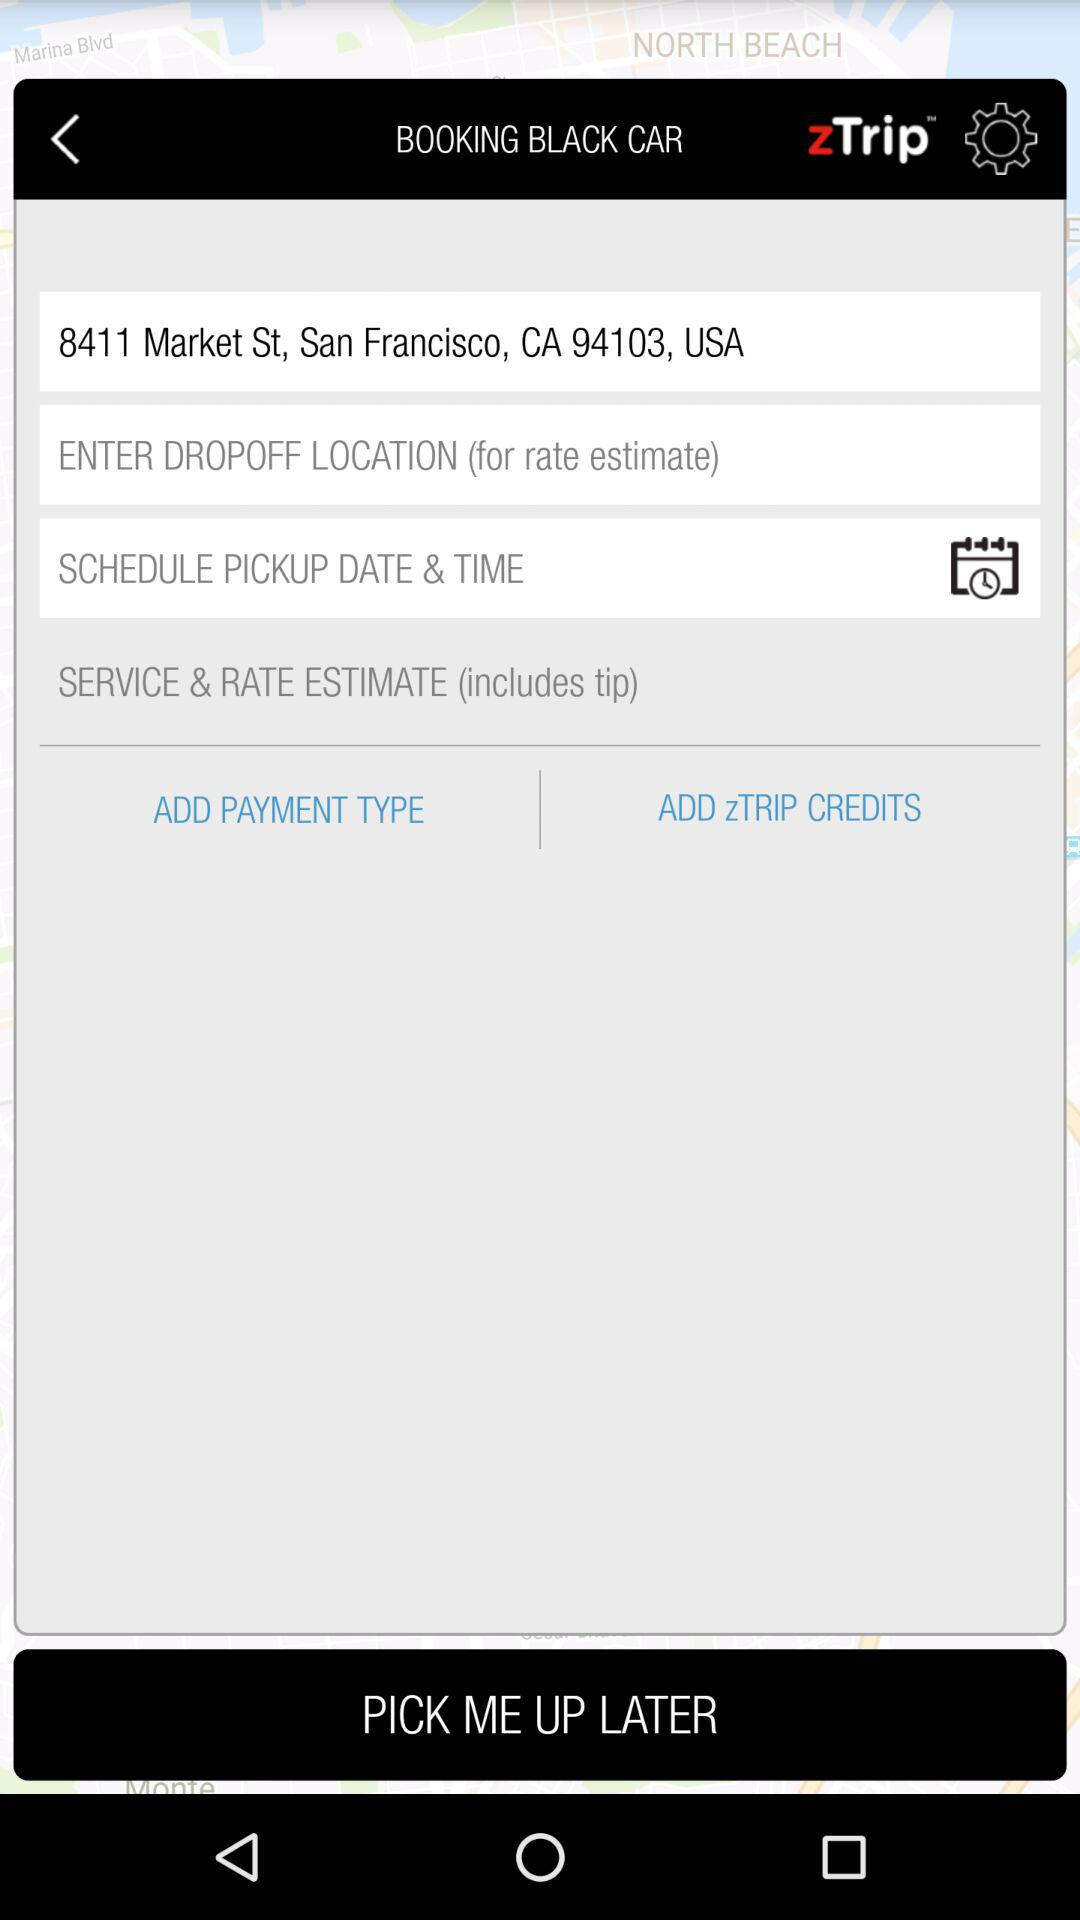What is the location? The location is "8411 Market St, San Fancisco, CA 94103, USA". 